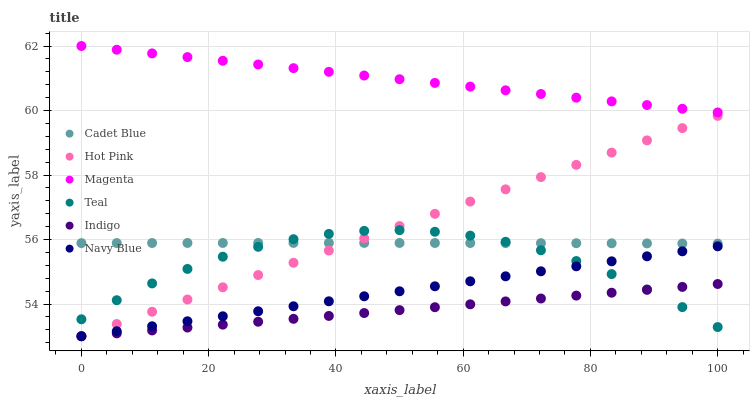Does Indigo have the minimum area under the curve?
Answer yes or no. Yes. Does Magenta have the maximum area under the curve?
Answer yes or no. Yes. Does Navy Blue have the minimum area under the curve?
Answer yes or no. No. Does Navy Blue have the maximum area under the curve?
Answer yes or no. No. Is Magenta the smoothest?
Answer yes or no. Yes. Is Teal the roughest?
Answer yes or no. Yes. Is Indigo the smoothest?
Answer yes or no. No. Is Indigo the roughest?
Answer yes or no. No. Does Indigo have the lowest value?
Answer yes or no. Yes. Does Teal have the lowest value?
Answer yes or no. No. Does Magenta have the highest value?
Answer yes or no. Yes. Does Navy Blue have the highest value?
Answer yes or no. No. Is Navy Blue less than Magenta?
Answer yes or no. Yes. Is Magenta greater than Navy Blue?
Answer yes or no. Yes. Does Indigo intersect Hot Pink?
Answer yes or no. Yes. Is Indigo less than Hot Pink?
Answer yes or no. No. Is Indigo greater than Hot Pink?
Answer yes or no. No. Does Navy Blue intersect Magenta?
Answer yes or no. No. 